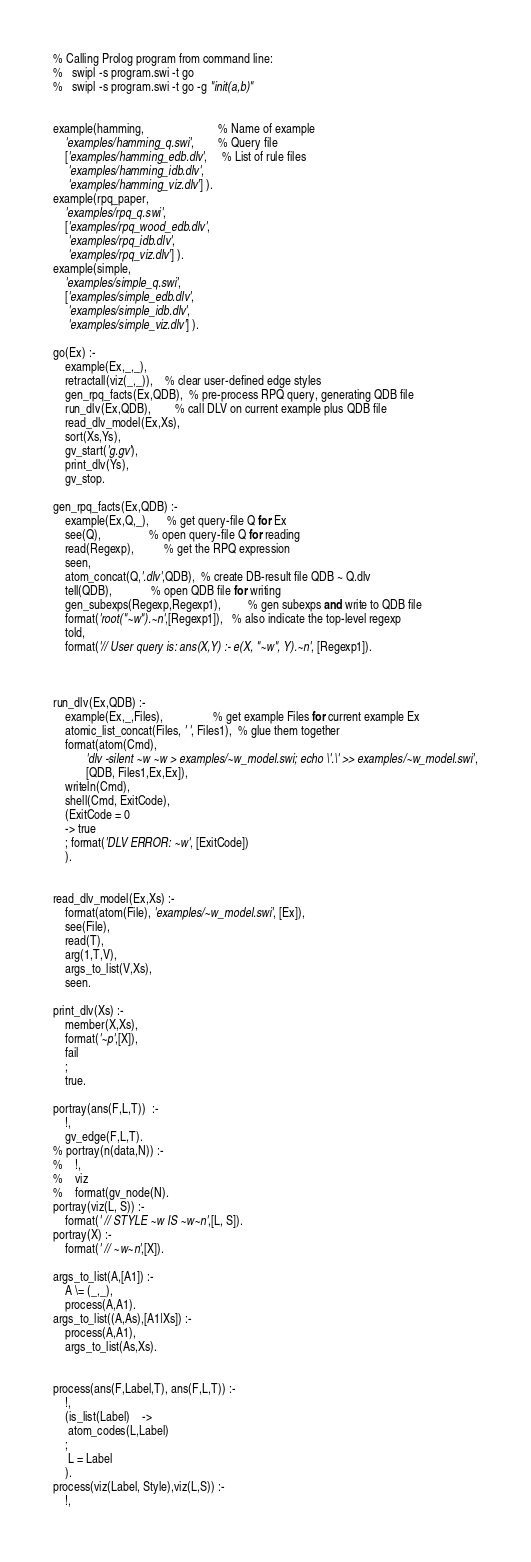<code> <loc_0><loc_0><loc_500><loc_500><_Perl_>% Calling Prolog program from command line:
%   swipl -s program.swi -t go
%   swipl -s program.swi -t go -g "init(a,b)"


example(hamming,                         % Name of example
	'examples/hamming_q.swi',        % Query file 
	['examples/hamming_edb.dlv',     % List of rule files		
	 'examples/hamming_idb.dlv',		
	 'examples/hamming_viz.dlv'] ).		
example(rpq_paper,
	'examples/rpq_q.swi',
	['examples/rpq_wood_edb.dlv',		
	 'examples/rpq_idb.dlv',		
	 'examples/rpq_viz.dlv'] ).		
example(simple,
	'examples/simple_q.swi',
	['examples/simple_edb.dlv',		
	 'examples/simple_idb.dlv',		
	 'examples/simple_viz.dlv'] ).		

go(Ex) :-
    example(Ex,_,_),
    retractall(viz(_,_)),	% clear user-defined edge styles
    gen_rpq_facts(Ex,QDB),  % pre-process RPQ query, generating QDB file
    run_dlv(Ex,QDB),        % call DLV on current example plus QDB file
    read_dlv_model(Ex,Xs),
    sort(Xs,Ys), 
    gv_start('g.gv'),
    print_dlv(Ys),
    gv_stop.

gen_rpq_facts(Ex,QDB) :-
	example(Ex,Q,_),      % get query-file Q for Ex
	see(Q),                % open query-file Q for reading 
	read(Regexp),          % get the RPQ expression
	seen,
	atom_concat(Q,'.dlv',QDB),  % create DB-result file QDB ~ Q.dlv
	tell(QDB),             % open QDB file for writing
	gen_subexps(Regexp,Regexp1),         % gen subexps and write to QDB file
	format('root("~w").~n',[Regexp1]),   % also indicate the top-level regexp
	told,
	format('// User query is: ans(X,Y) :- e(X, "~w", Y).~n', [Regexp1]). 



run_dlv(Ex,QDB) :-
	example(Ex,_,Files),                 % get example Files for current example Ex
	atomic_list_concat(Files, ' ', Files1),  % glue them together
	format(atom(Cmd),
	       'dlv -silent ~w ~w > examples/~w_model.swi; echo \'.\' >> examples/~w_model.swi',
	       [QDB, Files1,Ex,Ex]),
	writeln(Cmd),
	shell(Cmd, ExitCode),
	(ExitCode = 0
	-> true
	; format('DLV ERROR: ~w', [ExitCode])
	).


read_dlv_model(Ex,Xs) :-
	format(atom(File), 'examples/~w_model.swi', [Ex]),
	see(File),
	read(T),
	arg(1,T,V),
	args_to_list(V,Xs),
	seen.

print_dlv(Xs) :-
	member(X,Xs),
	format('~p',[X]),
	fail
	;
	true.

portray(ans(F,L,T))  :-
	!,
	gv_edge(F,L,T).
% portray(n(data,N)) :-
% 	!,
% 	viz
% 	format(gv_node(N).
portray(viz(L, S)) :-
	format(' // STYLE ~w IS ~w~n',[L, S]).
portray(X) :-
	format(' // ~w~n',[X]).

args_to_list(A,[A1]) :-
	A \= (_,_),
	process(A,A1).
args_to_list((A,As),[A1|Xs]) :-
	process(A,A1),
	args_to_list(As,Xs).


process(ans(F,Label,T), ans(F,L,T)) :-
	!,
 	(is_list(Label)	->
	 atom_codes(L,Label)
 	;
	 L = Label
 	).
process(viz(Label, Style),viz(L,S)) :-
	!,</code> 